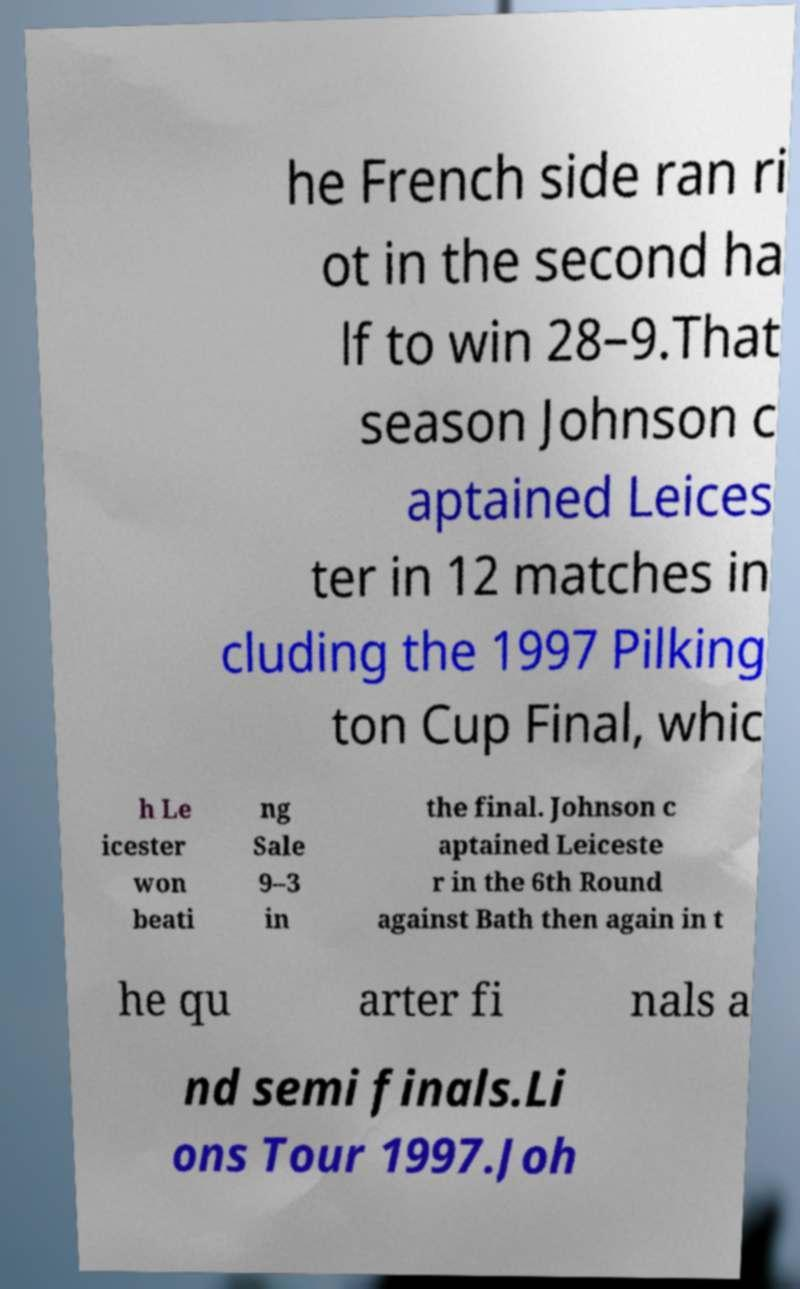What messages or text are displayed in this image? I need them in a readable, typed format. he French side ran ri ot in the second ha lf to win 28–9.That season Johnson c aptained Leices ter in 12 matches in cluding the 1997 Pilking ton Cup Final, whic h Le icester won beati ng Sale 9–3 in the final. Johnson c aptained Leiceste r in the 6th Round against Bath then again in t he qu arter fi nals a nd semi finals.Li ons Tour 1997.Joh 